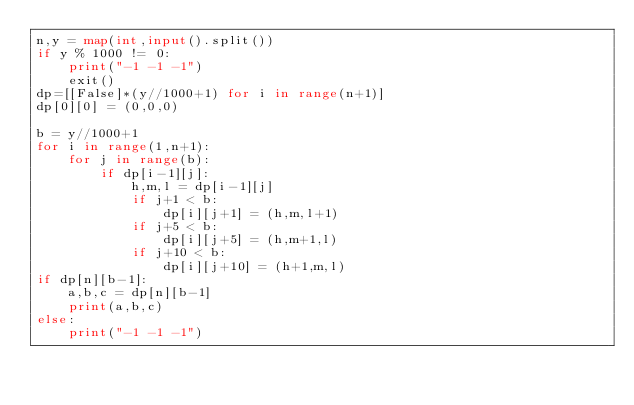<code> <loc_0><loc_0><loc_500><loc_500><_Python_>n,y = map(int,input().split())
if y % 1000 != 0:
    print("-1 -1 -1")
    exit()
dp=[[False]*(y//1000+1) for i in range(n+1)]
dp[0][0] = (0,0,0)

b = y//1000+1
for i in range(1,n+1):
    for j in range(b):
        if dp[i-1][j]:
            h,m,l = dp[i-1][j]
            if j+1 < b:
                dp[i][j+1] = (h,m,l+1)
            if j+5 < b:
                dp[i][j+5] = (h,m+1,l)
            if j+10 < b:
                dp[i][j+10] = (h+1,m,l)
if dp[n][b-1]:
    a,b,c = dp[n][b-1]
    print(a,b,c)
else:
    print("-1 -1 -1")</code> 